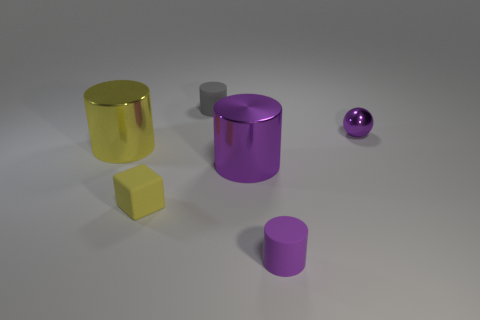Subtract all yellow metallic cylinders. How many cylinders are left? 3 Add 2 small objects. How many objects exist? 8 Subtract all purple cylinders. How many cylinders are left? 2 Subtract all cylinders. How many objects are left? 2 Subtract 1 cylinders. How many cylinders are left? 3 Subtract 1 gray cylinders. How many objects are left? 5 Subtract all blue balls. Subtract all gray blocks. How many balls are left? 1 Subtract all yellow blocks. How many brown spheres are left? 0 Subtract all cyan metallic cylinders. Subtract all tiny gray matte objects. How many objects are left? 5 Add 1 tiny purple objects. How many tiny purple objects are left? 3 